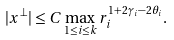<formula> <loc_0><loc_0><loc_500><loc_500>| x ^ { \perp } | \leq C \max _ { 1 \leq i \leq k } r ^ { 1 + 2 \gamma _ { i } - 2 \theta _ { i } } _ { i } .</formula> 